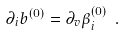<formula> <loc_0><loc_0><loc_500><loc_500>\partial _ { i } b ^ { ( 0 ) } = \partial _ { v } \beta ^ { ( 0 ) } _ { i } \ .</formula> 